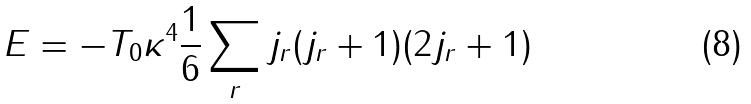<formula> <loc_0><loc_0><loc_500><loc_500>E = - T _ { 0 } \kappa ^ { 4 } \frac { 1 } { 6 } \sum _ { r } j _ { r } ( j _ { r } + 1 ) ( 2 j _ { r } + 1 )</formula> 